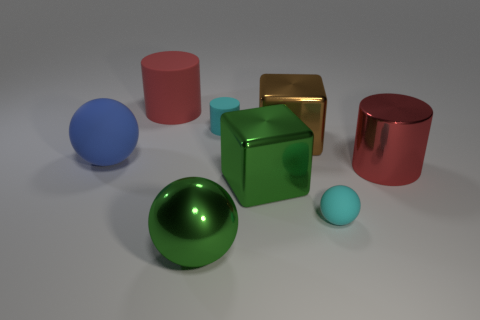How would you describe the lighting in this scene? The lighting in the scene can be characterized as soft and diffuse, creating subtle shadows and gentle highlights on the surfaces of the objects, which contributes to a calm and balanced ambiance. 